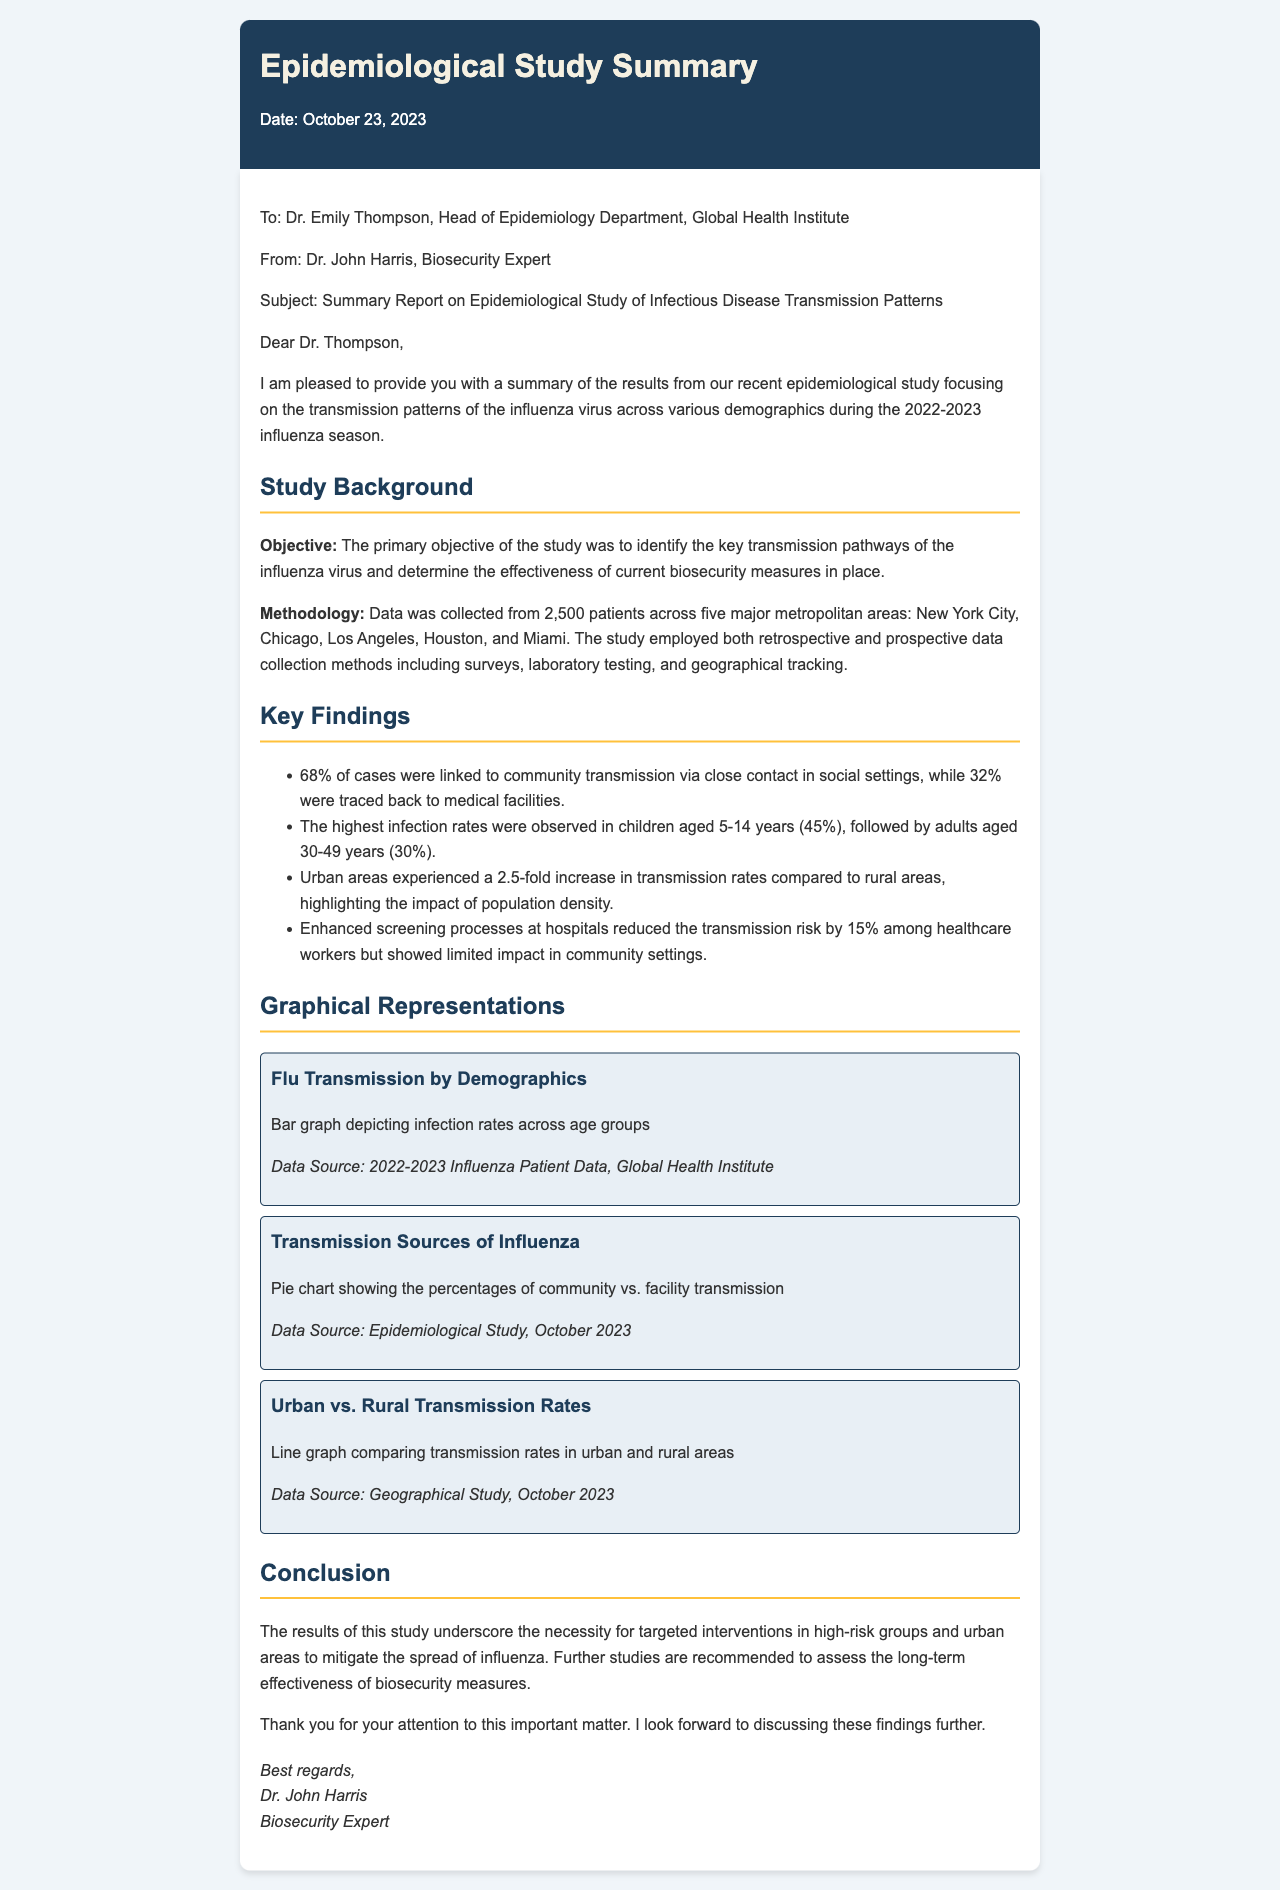What is the date of the letter? The date is explicitly stated at the beginning of the letter as October 23, 2023.
Answer: October 23, 2023 Who is the recipient of the letter? The letter is addressed to Dr. Emily Thompson, Head of Epidemiology Department, Global Health Institute.
Answer: Dr. Emily Thompson What percentage of cases were linked to community transmission? According to the findings, 68% of cases were attributed to community transmission via close contact.
Answer: 68% What age group had the highest infection rates? The highest infection rates were noted in children aged 5-14 years, indicating a specific demographic impacted most.
Answer: 5-14 years What is the impact of population density on transmission rates? The study highlights that urban areas had a 2.5-fold increase in transmission rates compared to rural areas, showing the effect of density.
Answer: 2.5-fold What was the reduction in transmission risk among healthcare workers? Enhanced screening processes at hospitals reduced the transmission risk by 15% among healthcare workers, according to the study.
Answer: 15% What type of graphs are included in the document? The document includes bar graphs, pie charts, and line graphs to visually represent the data.
Answer: Bar graph, pie chart, line graph What does the conclusion suggest regarding interventions? The conclusion emphasizes the need for targeted interventions in high-risk groups and urban areas to effectively address influenza spread.
Answer: Targeted interventions What is the sender's title? The sender, Dr. John Harris, identifies himself as a Biosecurity Expert in the closing of the letter.
Answer: Biosecurity Expert 